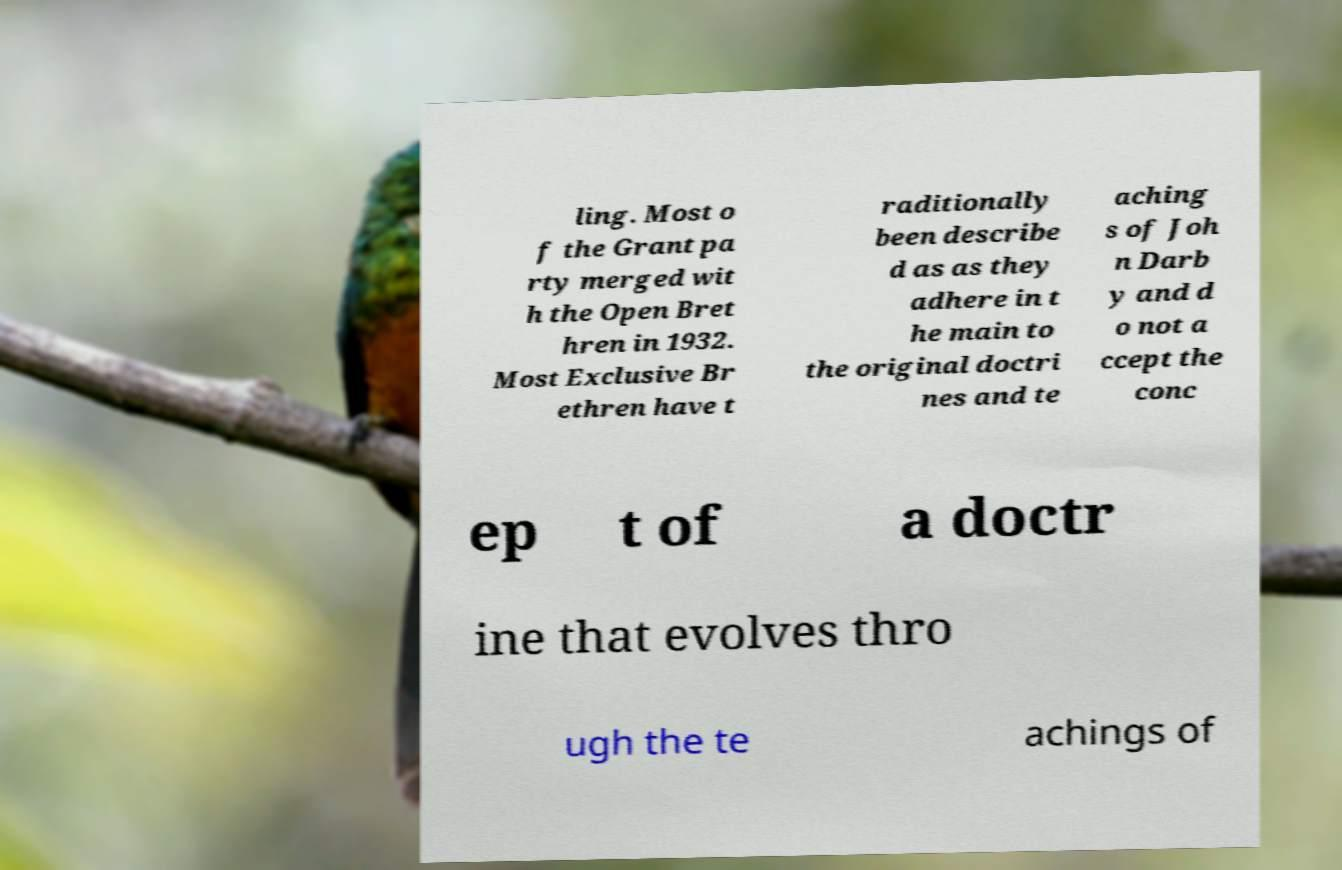Could you assist in decoding the text presented in this image and type it out clearly? ling. Most o f the Grant pa rty merged wit h the Open Bret hren in 1932. Most Exclusive Br ethren have t raditionally been describe d as as they adhere in t he main to the original doctri nes and te aching s of Joh n Darb y and d o not a ccept the conc ep t of a doctr ine that evolves thro ugh the te achings of 